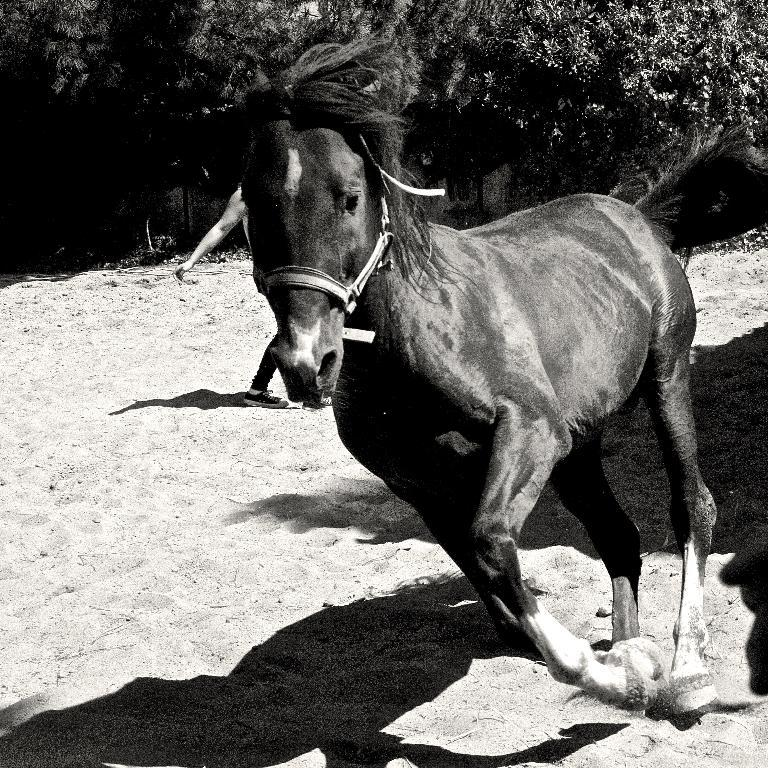What type of picture is in the image? The image contains a black and white picture. What is the main subject of the picture? There is a horse standing on the sand in the picture. What can be seen in the background of the picture? There are trees and a person standing on the sand visible in the background of the picture. What type of action is the horse performing in the picture? There is no specific action being performed by the horse in the picture; it is simply standing on the sand. 